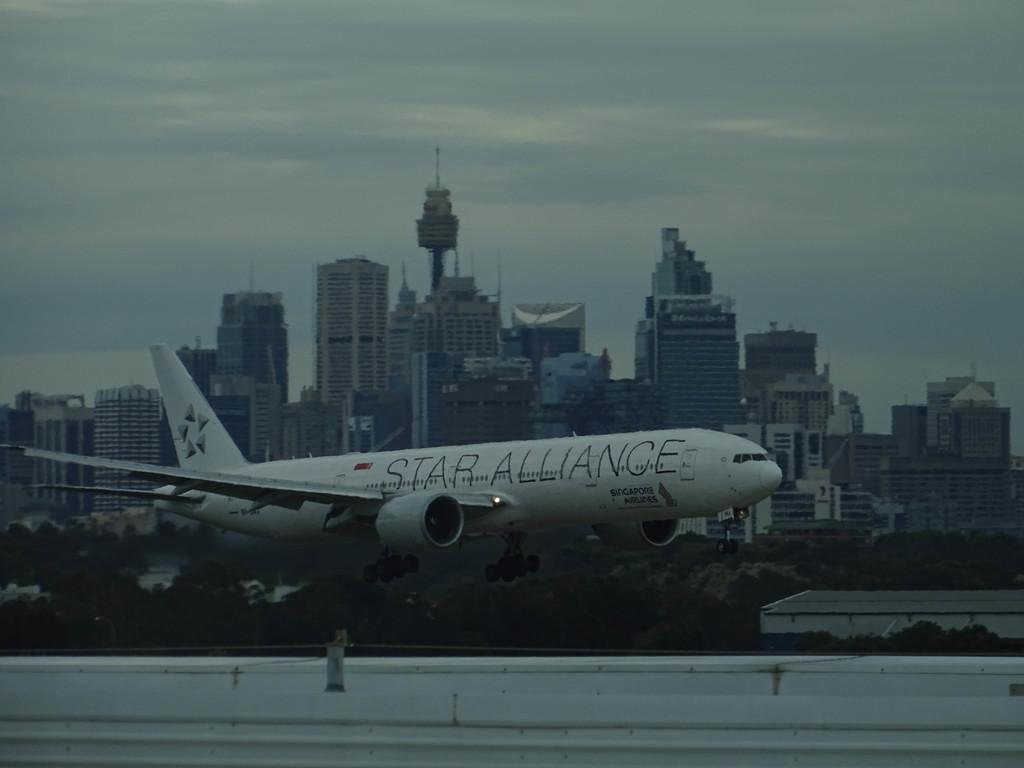<image>
Give a short and clear explanation of the subsequent image. a plane with the words 'star alliance' on the side of it 